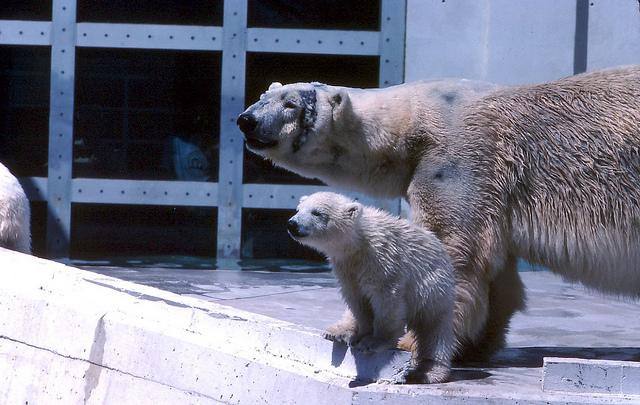Are these animals in the wild?
Answer briefly. No. What kind of animals are in this picture?
Keep it brief. Polar bears. Where was the picture taken?
Be succinct. Zoo. 